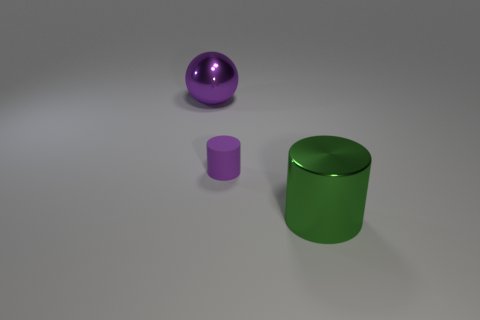Subtract all green cylinders. How many cylinders are left? 1 Add 3 shiny cylinders. How many objects exist? 6 Subtract all balls. How many objects are left? 2 Subtract all blue cylinders. Subtract all brown cubes. How many cylinders are left? 2 Subtract all big blue metal objects. Subtract all purple rubber objects. How many objects are left? 2 Add 2 big objects. How many big objects are left? 4 Add 2 blue objects. How many blue objects exist? 2 Subtract 0 blue cylinders. How many objects are left? 3 Subtract 1 cylinders. How many cylinders are left? 1 